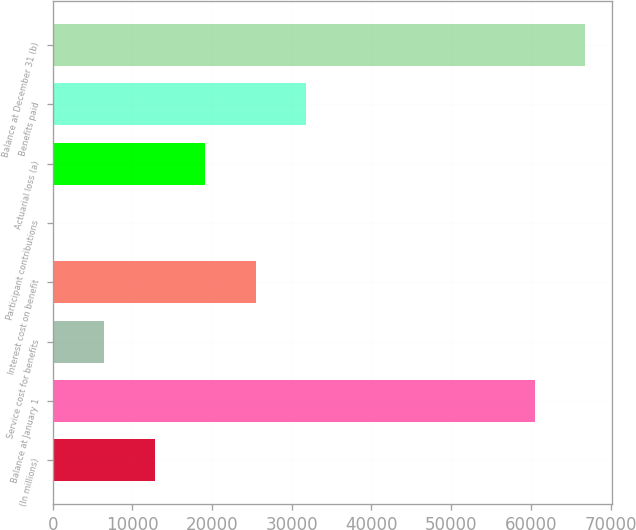Convert chart. <chart><loc_0><loc_0><loc_500><loc_500><bar_chart><fcel>(In millions)<fcel>Balance at January 1<fcel>Service cost for benefits<fcel>Interest cost on benefit<fcel>Participant contributions<fcel>Actuarial loss (a)<fcel>Benefits paid<fcel>Balance at December 31 (b)<nl><fcel>12826<fcel>60510<fcel>6491.5<fcel>25495<fcel>157<fcel>19160.5<fcel>31829.5<fcel>66844.5<nl></chart> 